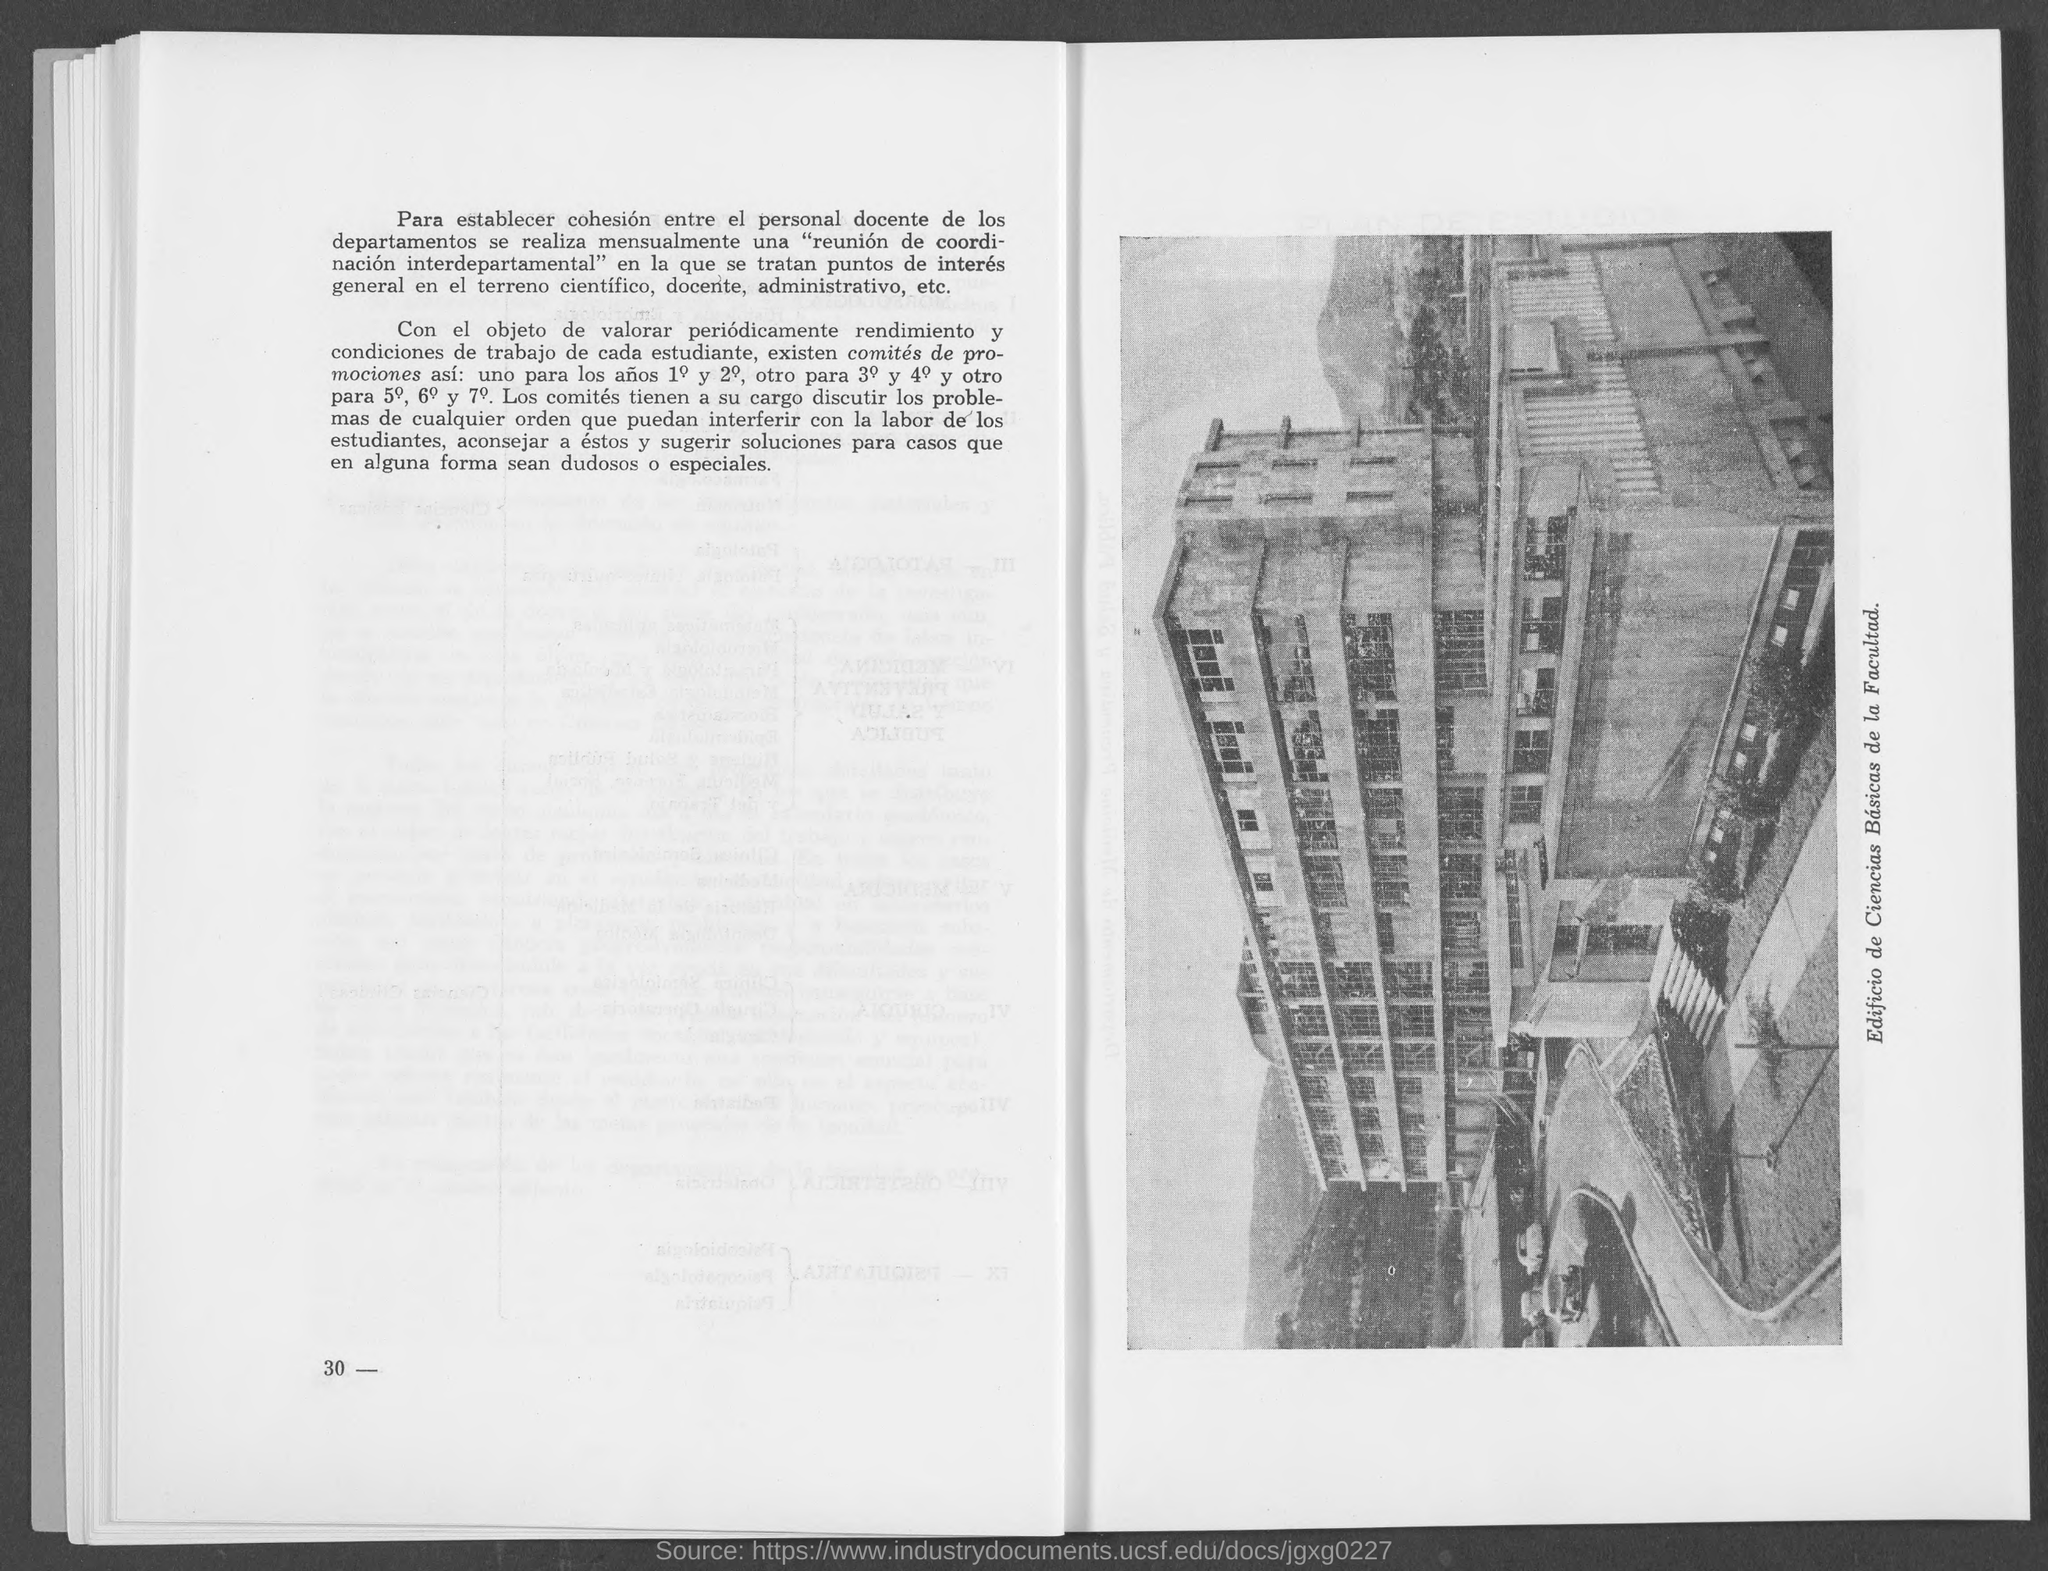What is the page number?
Make the answer very short. 30 -. 